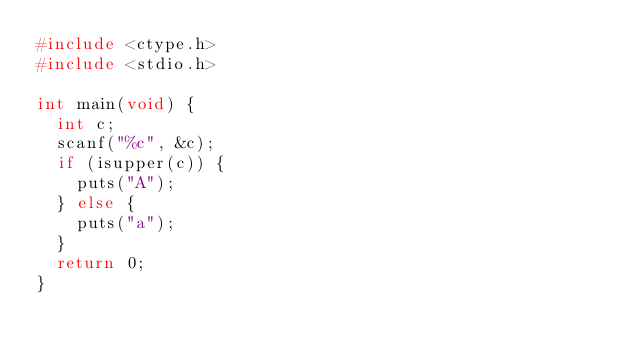Convert code to text. <code><loc_0><loc_0><loc_500><loc_500><_C_>#include <ctype.h>
#include <stdio.h>

int main(void) {
  int c;
  scanf("%c", &c);
  if (isupper(c)) {
    puts("A");
  } else {
    puts("a");
  }
  return 0;
}</code> 